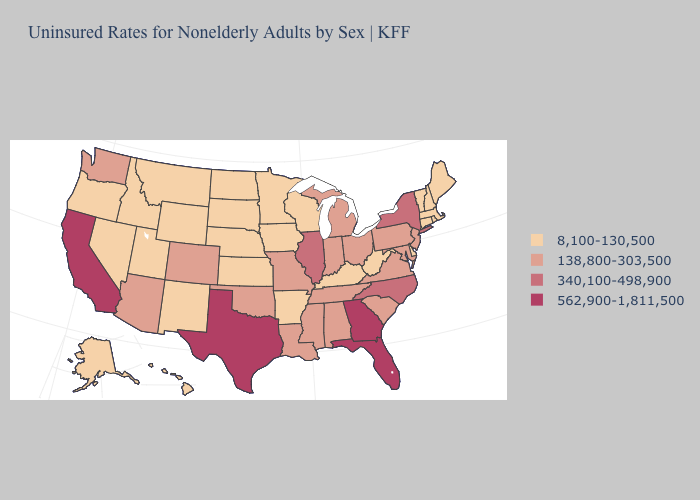Does the map have missing data?
Give a very brief answer. No. Among the states that border Kansas , which have the highest value?
Short answer required. Colorado, Missouri, Oklahoma. What is the value of Ohio?
Write a very short answer. 138,800-303,500. Does Colorado have the lowest value in the USA?
Keep it brief. No. What is the value of Idaho?
Write a very short answer. 8,100-130,500. Does North Carolina have the same value as Illinois?
Keep it brief. Yes. Which states have the highest value in the USA?
Be succinct. California, Florida, Georgia, Texas. What is the value of Pennsylvania?
Quick response, please. 138,800-303,500. Among the states that border West Virginia , which have the lowest value?
Answer briefly. Kentucky. What is the value of Virginia?
Concise answer only. 138,800-303,500. Name the states that have a value in the range 340,100-498,900?
Concise answer only. Illinois, New York, North Carolina. What is the value of Utah?
Write a very short answer. 8,100-130,500. What is the value of Maine?
Write a very short answer. 8,100-130,500. What is the value of North Dakota?
Give a very brief answer. 8,100-130,500. What is the highest value in states that border Vermont?
Concise answer only. 340,100-498,900. 